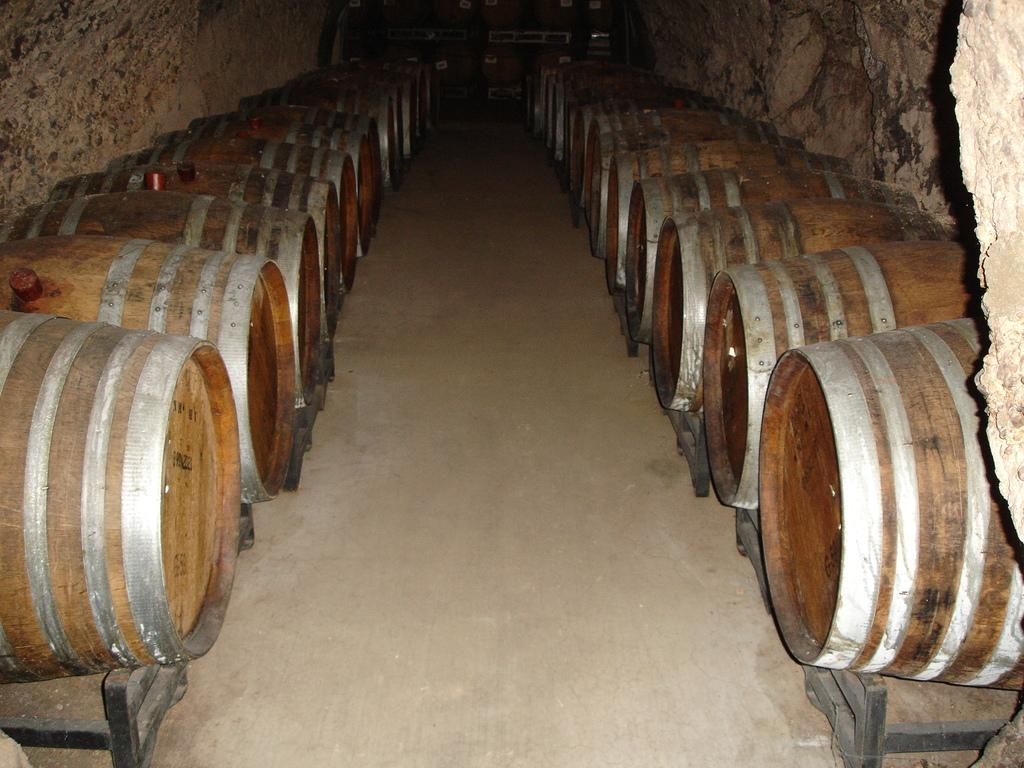What objects are on stands in the image? There are barrels on stands in the image. Can you describe the positioning of the barrels in the image? The barrels are placed on stands. What might the barrels be used for, based on their appearance in the image? The barrels on stands might be used for storage or as decorative elements. What type of circle can be seen on the dinner table in the image? There is no dinner table or circle present in the image; it features barrels on stands. What type of knife is being used to cut the dinner in the image? There is no dinner or knife present in the image. 